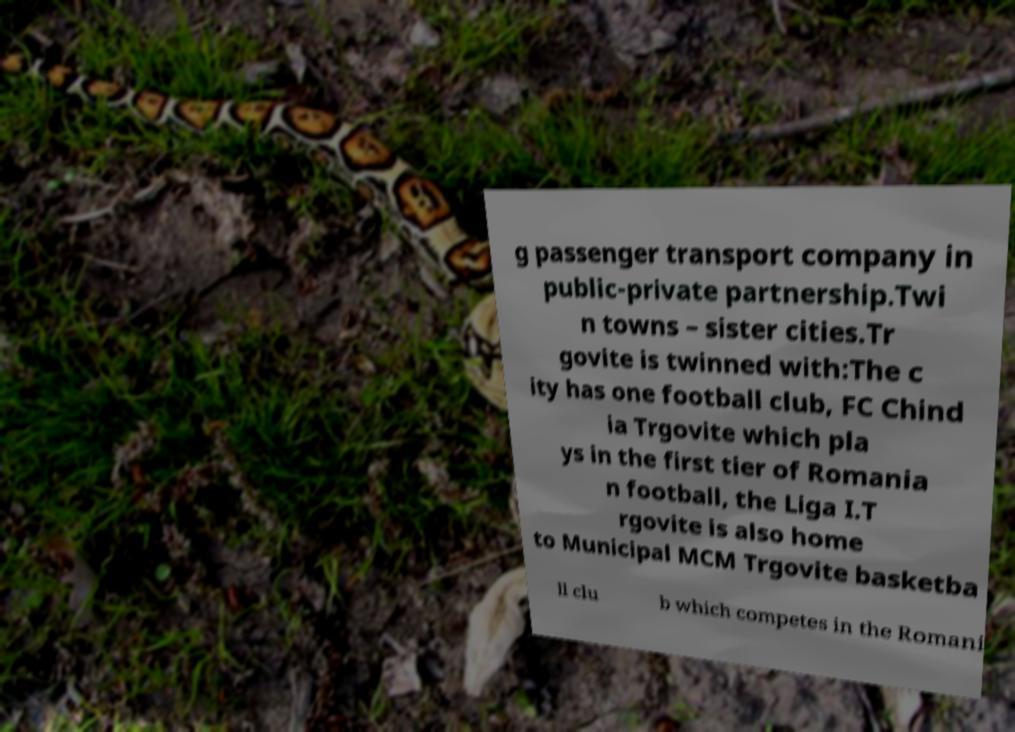There's text embedded in this image that I need extracted. Can you transcribe it verbatim? g passenger transport company in public-private partnership.Twi n towns – sister cities.Tr govite is twinned with:The c ity has one football club, FC Chind ia Trgovite which pla ys in the first tier of Romania n football, the Liga I.T rgovite is also home to Municipal MCM Trgovite basketba ll clu b which competes in the Romani 